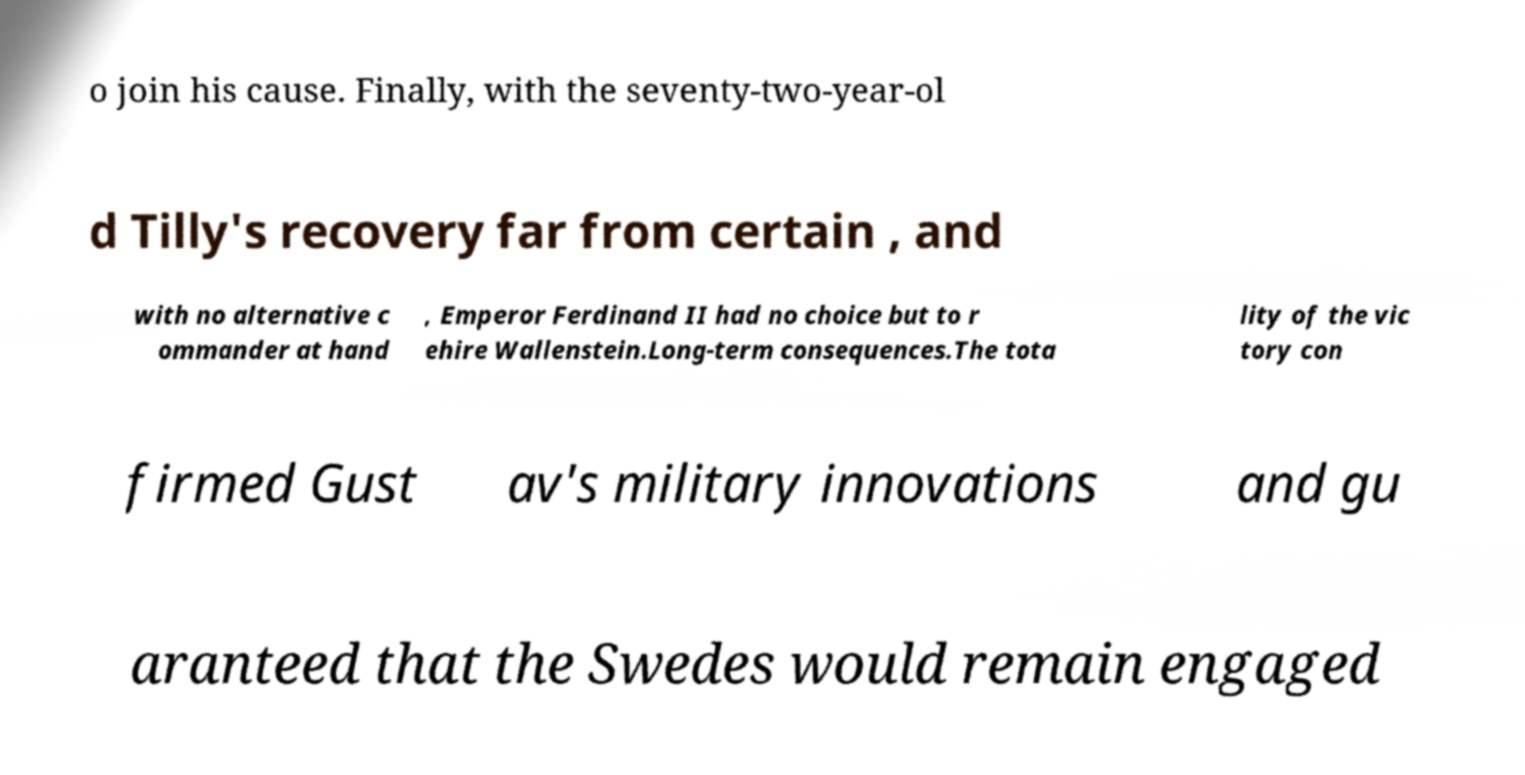Please read and relay the text visible in this image. What does it say? o join his cause. Finally, with the seventy-two-year-ol d Tilly's recovery far from certain , and with no alternative c ommander at hand , Emperor Ferdinand II had no choice but to r ehire Wallenstein.Long-term consequences.The tota lity of the vic tory con firmed Gust av's military innovations and gu aranteed that the Swedes would remain engaged 